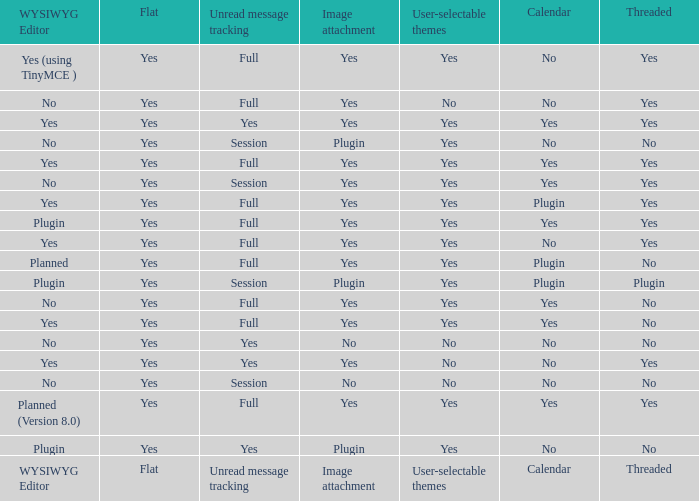Would you mind parsing the complete table? {'header': ['WYSIWYG Editor', 'Flat', 'Unread message tracking', 'Image attachment', 'User-selectable themes', 'Calendar', 'Threaded'], 'rows': [['Yes (using TinyMCE )', 'Yes', 'Full', 'Yes', 'Yes', 'No', 'Yes'], ['No', 'Yes', 'Full', 'Yes', 'No', 'No', 'Yes'], ['Yes', 'Yes', 'Yes', 'Yes', 'Yes', 'Yes', 'Yes'], ['No', 'Yes', 'Session', 'Plugin', 'Yes', 'No', 'No'], ['Yes', 'Yes', 'Full', 'Yes', 'Yes', 'Yes', 'Yes'], ['No', 'Yes', 'Session', 'Yes', 'Yes', 'Yes', 'Yes'], ['Yes', 'Yes', 'Full', 'Yes', 'Yes', 'Plugin', 'Yes'], ['Plugin', 'Yes', 'Full', 'Yes', 'Yes', 'Yes', 'Yes'], ['Yes', 'Yes', 'Full', 'Yes', 'Yes', 'No', 'Yes'], ['Planned', 'Yes', 'Full', 'Yes', 'Yes', 'Plugin', 'No'], ['Plugin', 'Yes', 'Session', 'Plugin', 'Yes', 'Plugin', 'Plugin'], ['No', 'Yes', 'Full', 'Yes', 'Yes', 'Yes', 'No'], ['Yes', 'Yes', 'Full', 'Yes', 'Yes', 'Yes', 'No'], ['No', 'Yes', 'Yes', 'No', 'No', 'No', 'No'], ['Yes', 'Yes', 'Yes', 'Yes', 'No', 'No', 'Yes'], ['No', 'Yes', 'Session', 'No', 'No', 'No', 'No'], ['Planned (Version 8.0)', 'Yes', 'Full', 'Yes', 'Yes', 'Yes', 'Yes'], ['Plugin', 'Yes', 'Yes', 'Plugin', 'Yes', 'No', 'No'], ['WYSIWYG Editor', 'Flat', 'Unread message tracking', 'Image attachment', 'User-selectable themes', 'Calendar', 'Threaded']]} Which Calendar has a User-selectable themes of user-selectable themes? Calendar. 